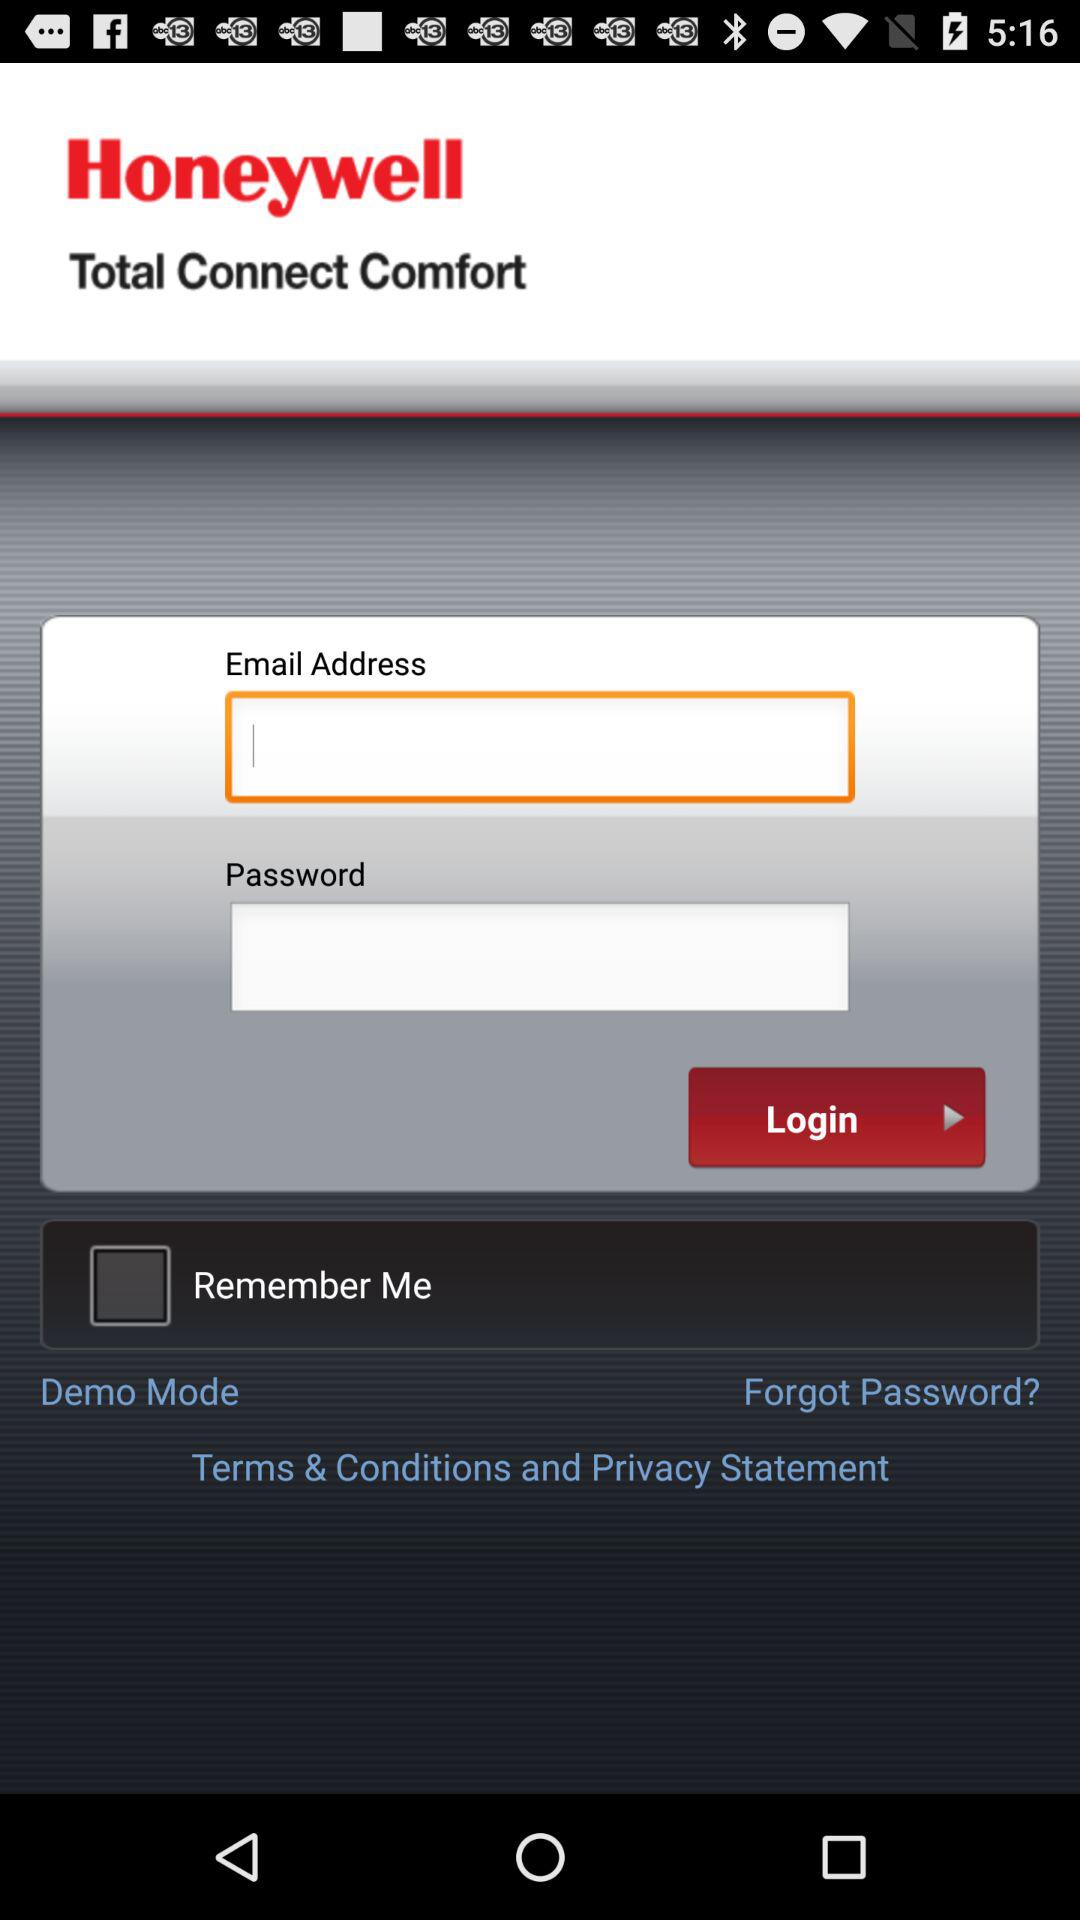What is the status of "Remember Me"? The status of "Remember Me" is "off". 